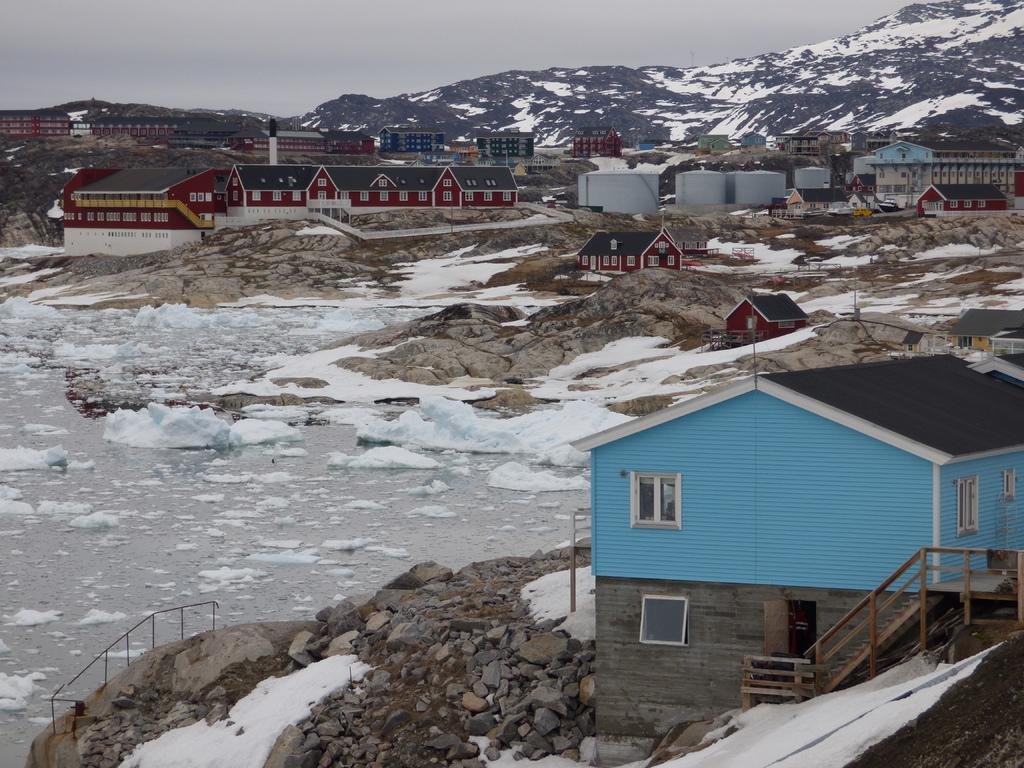What type of structures can be seen in the image? There are buildings in the image. What else can be seen besides the buildings? There are poles, rocks, icebergs, and hills visible in the image. What is the natural landscape like in the image? The image features hills and rocks, as well as icebergs, which suggests a cold environment. What part of the natural environment is visible in the image? The sky is visible in the image. How many crates are stacked next to the buildings in the image? There are no crates present in the image. What type of bikes can be seen parked near the icebergs in the image? There are no bikes present in the image. 